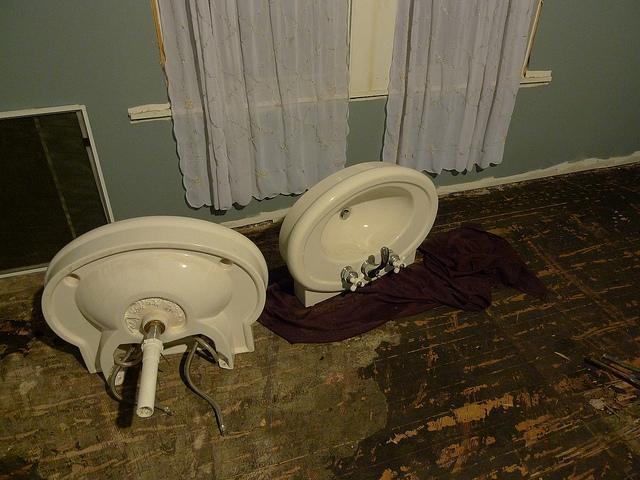How many people are on the bench?
Give a very brief answer. 0. 